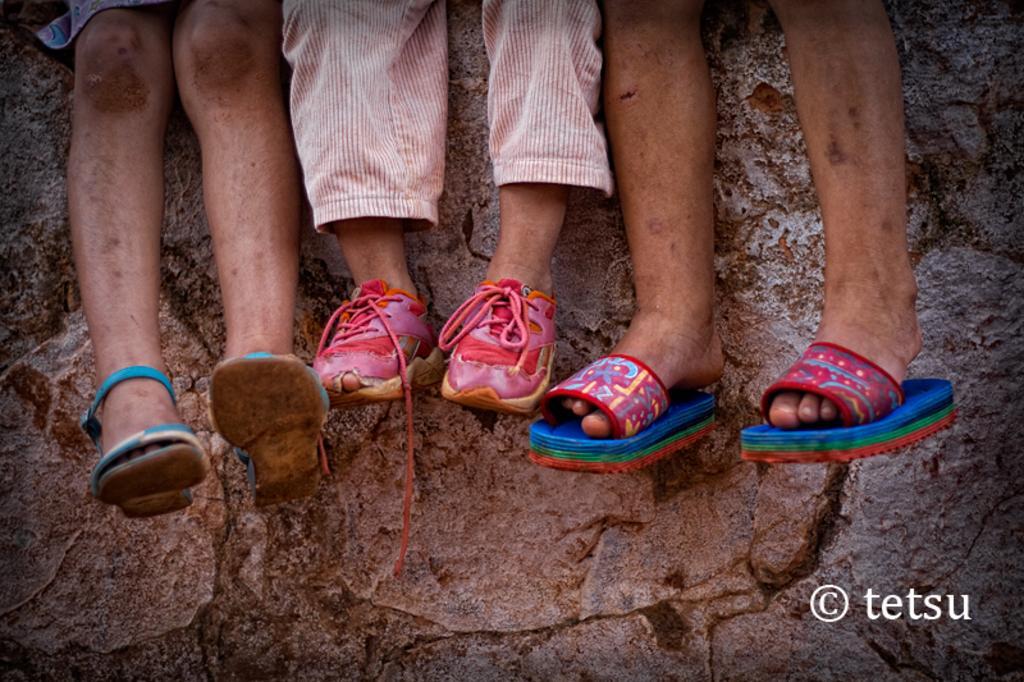In one or two sentences, can you explain what this image depicts? In this picture I can see few human legs, I can see footwear and looks like a rock in the background and text at the bottom right corner of the picture. 